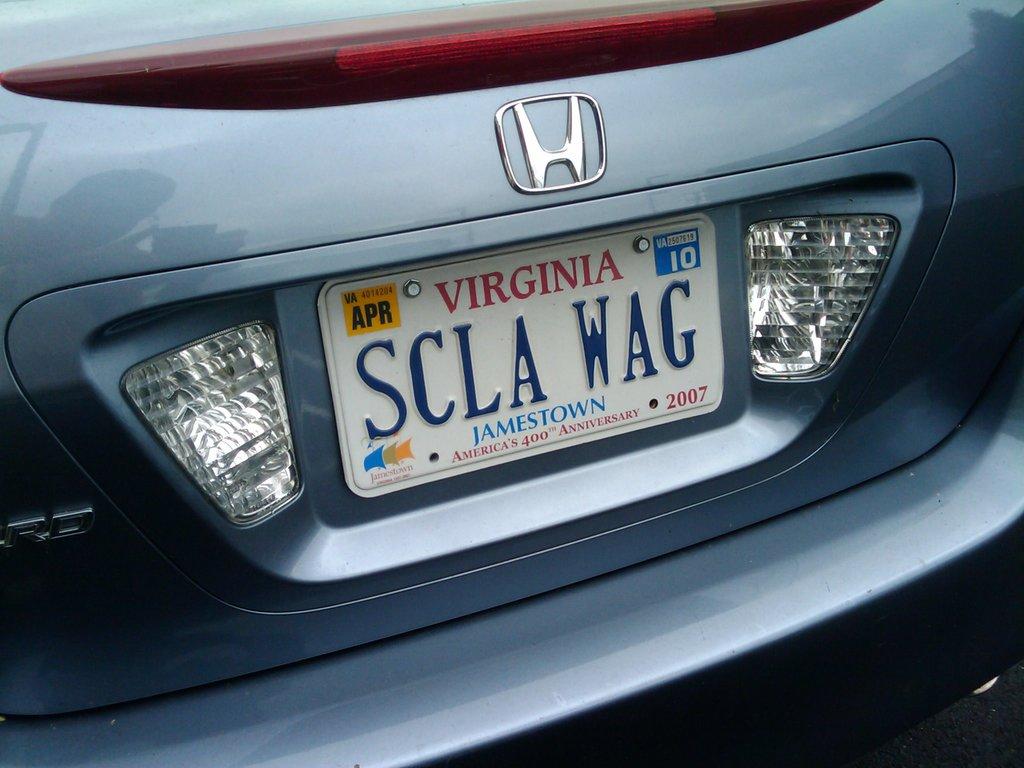What state is the plate from?
Offer a terse response. Virginia. What is the city on the plate?
Give a very brief answer. Jamestown. 